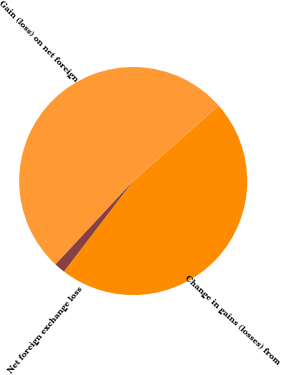<chart> <loc_0><loc_0><loc_500><loc_500><pie_chart><fcel>Change in gains (losses) from<fcel>Gain (loss) on net foreign<fcel>Net foreign exchange loss<nl><fcel>46.88%<fcel>51.56%<fcel>1.56%<nl></chart> 